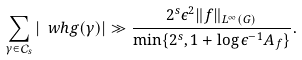Convert formula to latex. <formula><loc_0><loc_0><loc_500><loc_500>\sum _ { \gamma \in \mathcal { C } _ { s } } { | \ w h { g } ( \gamma ) | } \gg \frac { 2 ^ { s } \epsilon ^ { 2 } \| f \| _ { L ^ { \infty } ( G ) } } { \min \{ 2 ^ { s } , 1 + \log \epsilon ^ { - 1 } A _ { f } \} } .</formula> 